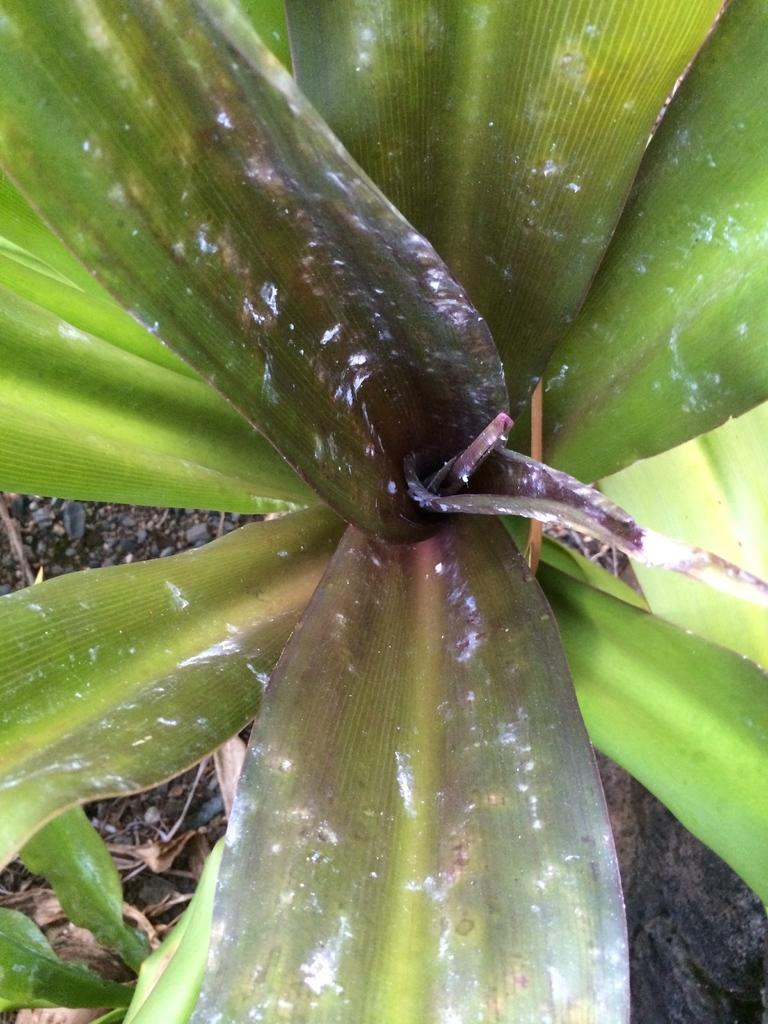What type of living organism is present in the image? There is a plant in the image. What color are the leaves of the plant? The leaves of the plant are green. What is visible at the bottom of the image? There is ground visible at the bottom of the image. What type of ornament is hanging from the plant in the image? There is no ornament present in the image; it only features a plant with green leaves. 